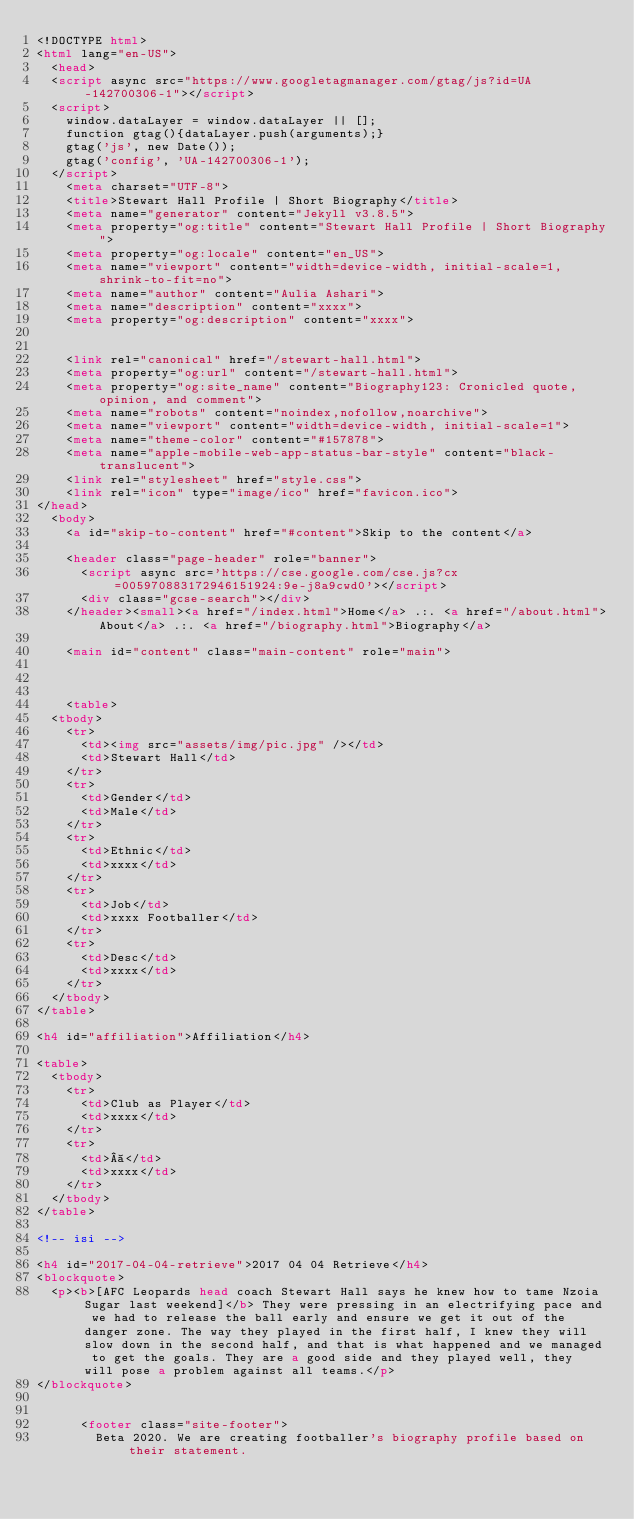Convert code to text. <code><loc_0><loc_0><loc_500><loc_500><_HTML_><!DOCTYPE html>
<html lang="en-US">
  <head>    
  <script async src="https://www.googletagmanager.com/gtag/js?id=UA-142700306-1"></script>
  <script>
    window.dataLayer = window.dataLayer || [];
    function gtag(){dataLayer.push(arguments);}
    gtag('js', new Date());
    gtag('config', 'UA-142700306-1');
  </script>
    <meta charset="UTF-8">
    <title>Stewart Hall Profile | Short Biography</title>
    <meta name="generator" content="Jekyll v3.8.5">
    <meta property="og:title" content="Stewart Hall Profile | Short Biography">
    <meta property="og:locale" content="en_US">
    <meta name="viewport" content="width=device-width, initial-scale=1, shrink-to-fit=no">
    <meta name="author" content="Aulia Ashari">
    <meta name="description" content="xxxx">
    <meta property="og:description" content="xxxx">
    
    
    <link rel="canonical" href="/stewart-hall.html">
    <meta property="og:url" content="/stewart-hall.html">
    <meta property="og:site_name" content="Biography123: Cronicled quote, opinion, and comment">
    <meta name="robots" content="noindex,nofollow,noarchive">
    <meta name="viewport" content="width=device-width, initial-scale=1">
    <meta name="theme-color" content="#157878">
    <meta name="apple-mobile-web-app-status-bar-style" content="black-translucent">
    <link rel="stylesheet" href="style.css">
    <link rel="icon" type="image/ico" href="favicon.ico">
</head>
  <body>
    <a id="skip-to-content" href="#content">Skip to the content</a>

    <header class="page-header" role="banner">
	    <script async src='https://cse.google.com/cse.js?cx=005970883172946151924:9e-j8a9cwd0'></script>
	    <div class="gcse-search"></div>      
    </header><small><a href="/index.html">Home</a> .:. <a href="/about.html">About</a> .:. <a href="/biography.html">Biography</a>
	    
    <main id="content" class="main-content" role="main">
	
    
    
    <table>
  <tbody>
    <tr>
      <td><img src="assets/img/pic.jpg" /></td>
      <td>Stewart Hall</td>
    </tr>
    <tr>
      <td>Gender</td>
      <td>Male</td>
    </tr>
    <tr>
      <td>Ethnic</td>
      <td>xxxx</td>
    </tr>
    <tr>
      <td>Job</td>
      <td>xxxx Footballer</td>
    </tr>
    <tr>
      <td>Desc</td>
      <td>xxxx</td>
    </tr>
  </tbody>
</table>

<h4 id="affiliation">Affiliation</h4>

<table>
  <tbody>
    <tr>
      <td>Club as Player</td>
      <td>xxxx</td>
    </tr>
    <tr>
      <td> </td>
      <td>xxxx</td>
    </tr>
  </tbody>
</table>

<!-- isi -->

<h4 id="2017-04-04-retrieve">2017 04 04 Retrieve</h4>
<blockquote>
  <p><b>[AFC Leopards head coach Stewart Hall says he knew how to tame Nzoia Sugar last weekend]</b> They were pressing in an electrifying pace and we had to release the ball early and ensure we get it out of the danger zone. The way they played in the first half, I knew they will slow down in the second half, and that is what happened and we managed to get the goals. They are a good side and they played well, they will pose a problem against all teams.</p>
</blockquote>

    
      <footer class="site-footer">	  
        Beta 2020. We are creating footballer's biography profile based on their statement.</code> 